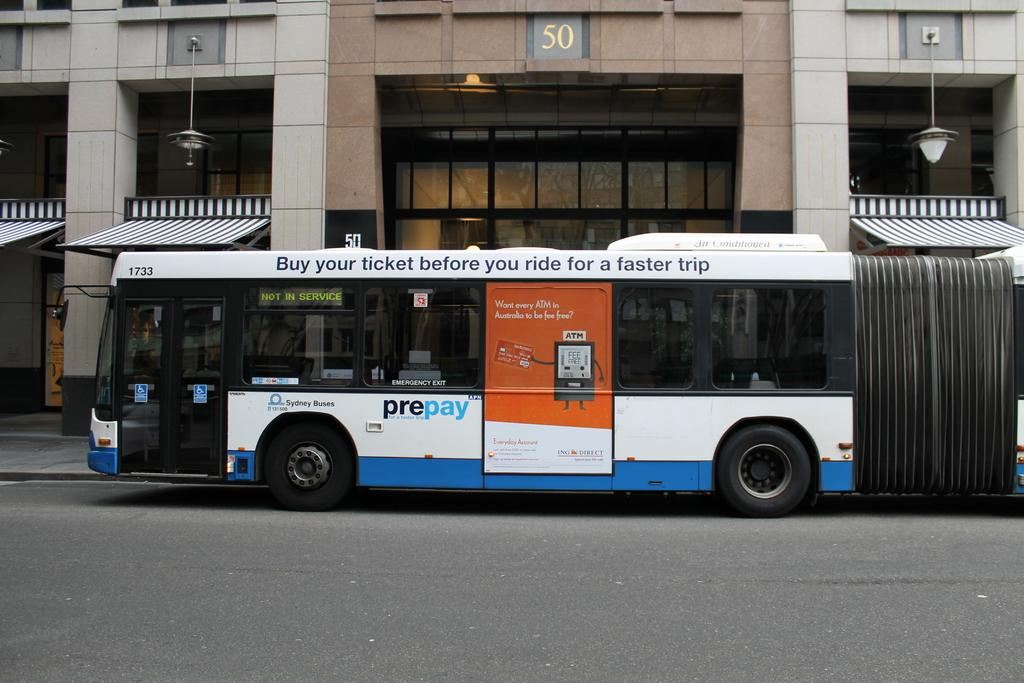<image>
Present a compact description of the photo's key features. A one decker bus with an advert for pre pay along the bottom . 